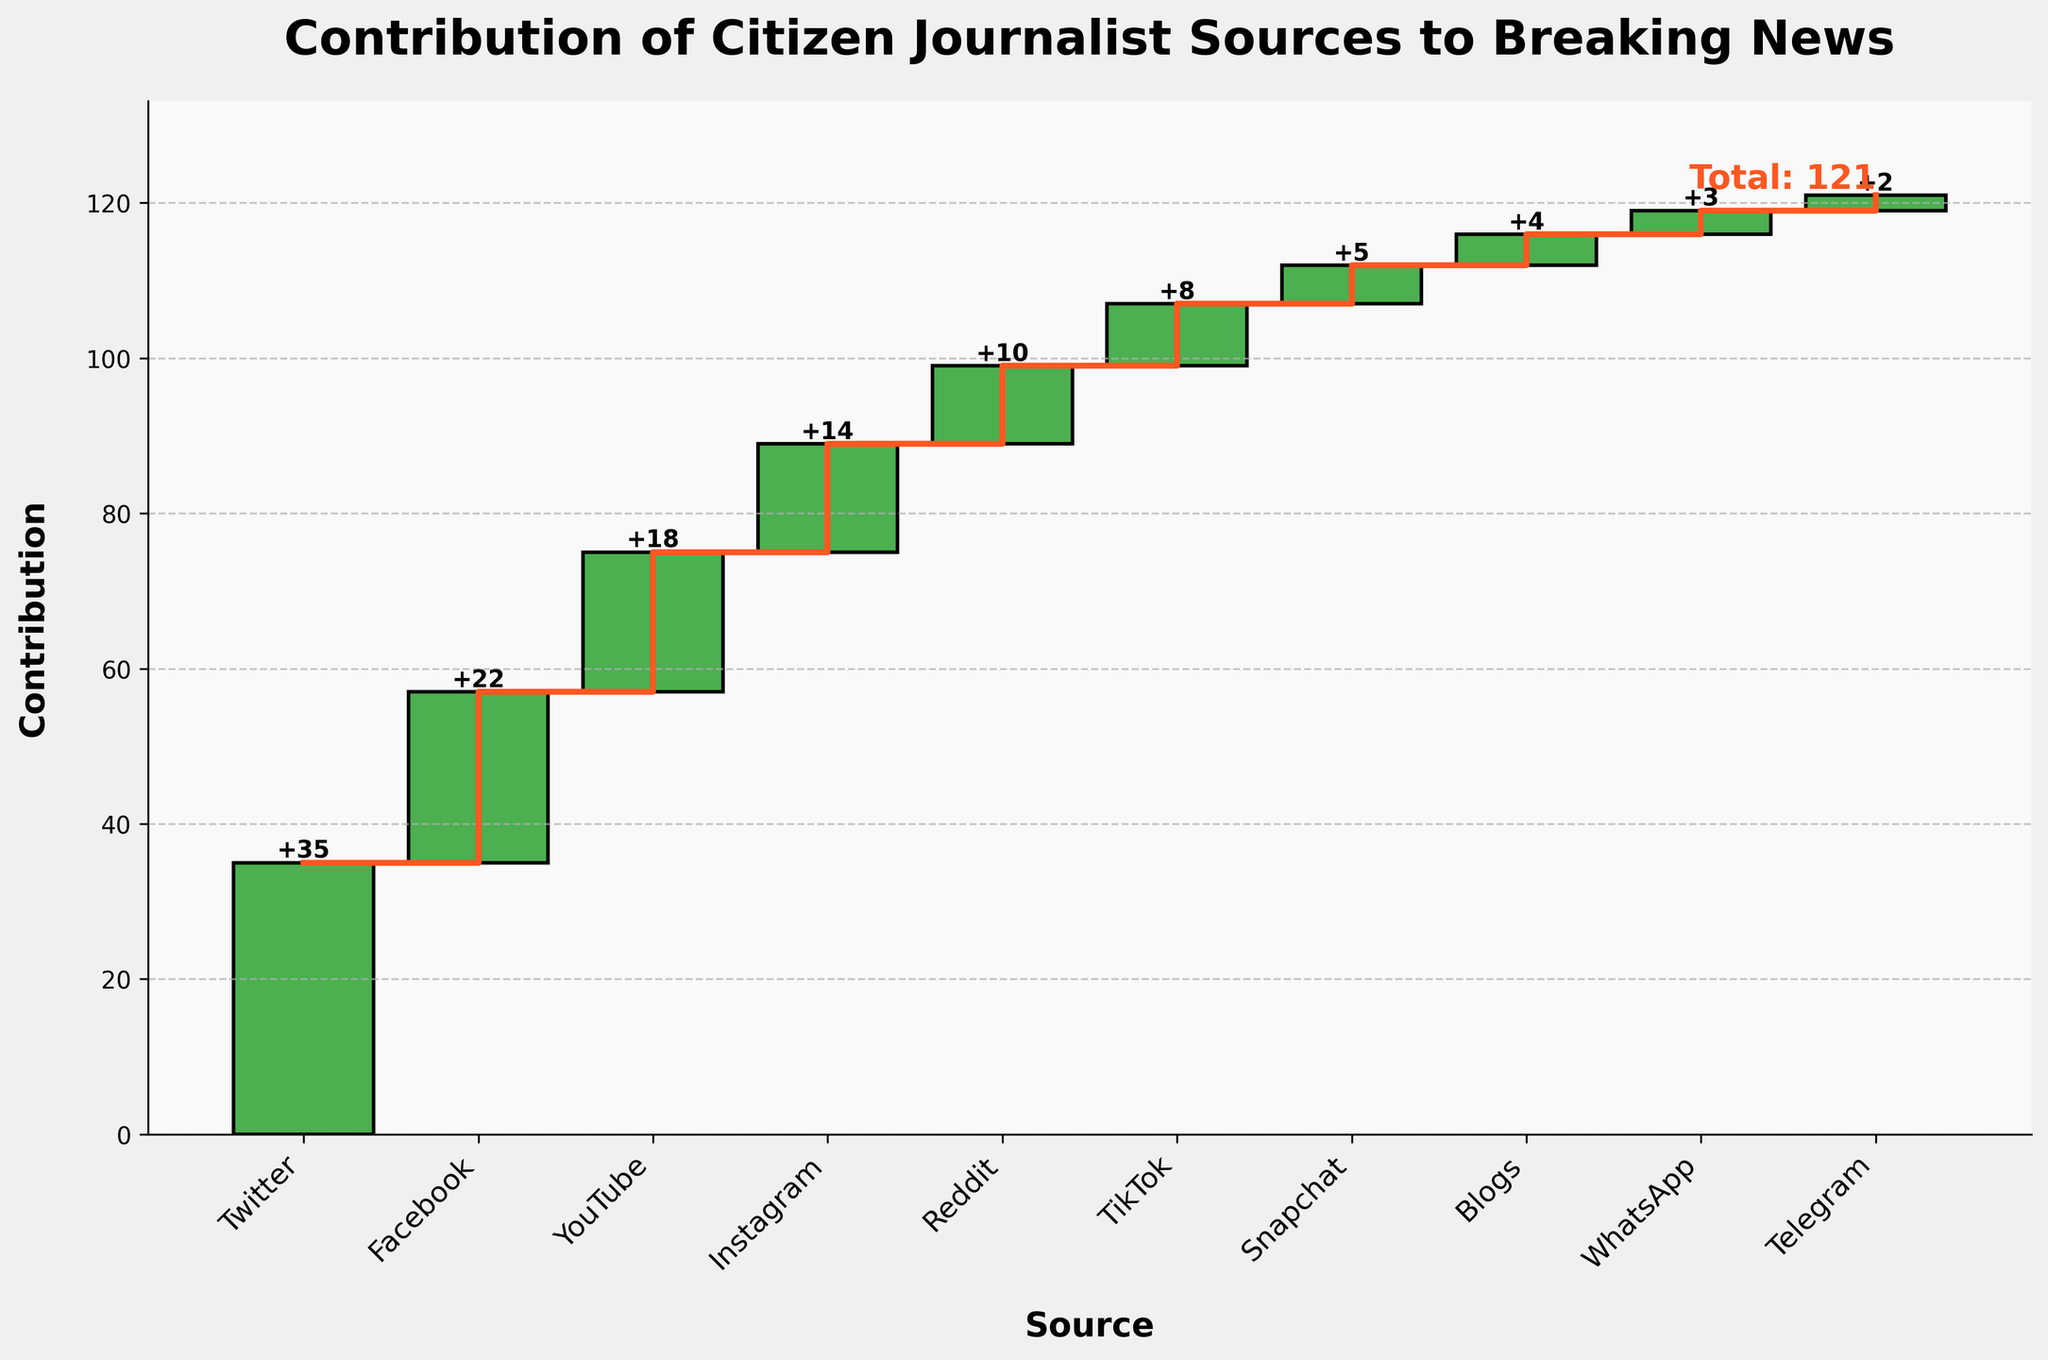What is the title of the figure? The title of the figure is generally displayed at the top of the chart. In this case, it indicates the subject being illustrated, which is related to the contribution of different citizen journalist sources.
Answer: Contribution of Citizen Journalist Sources to Breaking News Which source has the highest contribution to the breaking news? To determine the source with the highest contribution, look for the largest bar in the figure. This bar represents the source with the greatest addition.
Answer: Twitter What is the total contribution value shown in the figure? The total contribution value can be found at the far end of the cumulative line, often annotated directly on the chart.
Answer: 121 How much did Instagram contribute to the breaking news? Find the bar labeled "Instagram" and check the value annotated above it. This value indicates Instagram's contribution.
Answer: 14 What is the combined contribution of YouTube and Reddit? Add the contributions of YouTube and Reddit by locating their respective bars and summing their values: 18 (YouTube) + 10 (Reddit).
Answer: 28 Which two sources have the smallest contributions, and what are their values? Identify the two smallest bars on the chart, indicating the sources with the least contributions. They are likely annotated with their specific values.
Answer: Telegram (2) and WhatsApp (3) How many sources contribute more than 15 units? Count the number of bars with values greater than 15. These bars indicate sources with contributions exceeding 15 units.
Answer: 3 What is the contribution difference between Facebook and TikTok? Subtract the contribution of TikTok from Facebook's contribution: 22 (Facebook) - 8 (TikTok).
Answer: 14 What percentage of the total contribution comes from Facebook? Divide Facebook's contribution by the total contribution and multiply by 100%: (22 / 121) * 100%.
Answer: Approximately 18.18% Which source’s contribution brings the cumulative total closest to 100? Look for the source after which the cumulative line gets closest to, but does not exceed, the value of 100. This is often best visualized by following the cumulative line step-by-step.
Answer: Snapchat 